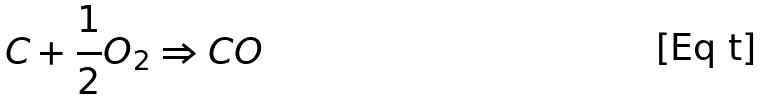Convert formula to latex. <formula><loc_0><loc_0><loc_500><loc_500>C + \frac { 1 } { 2 } O _ { 2 } \Rightarrow C O</formula> 